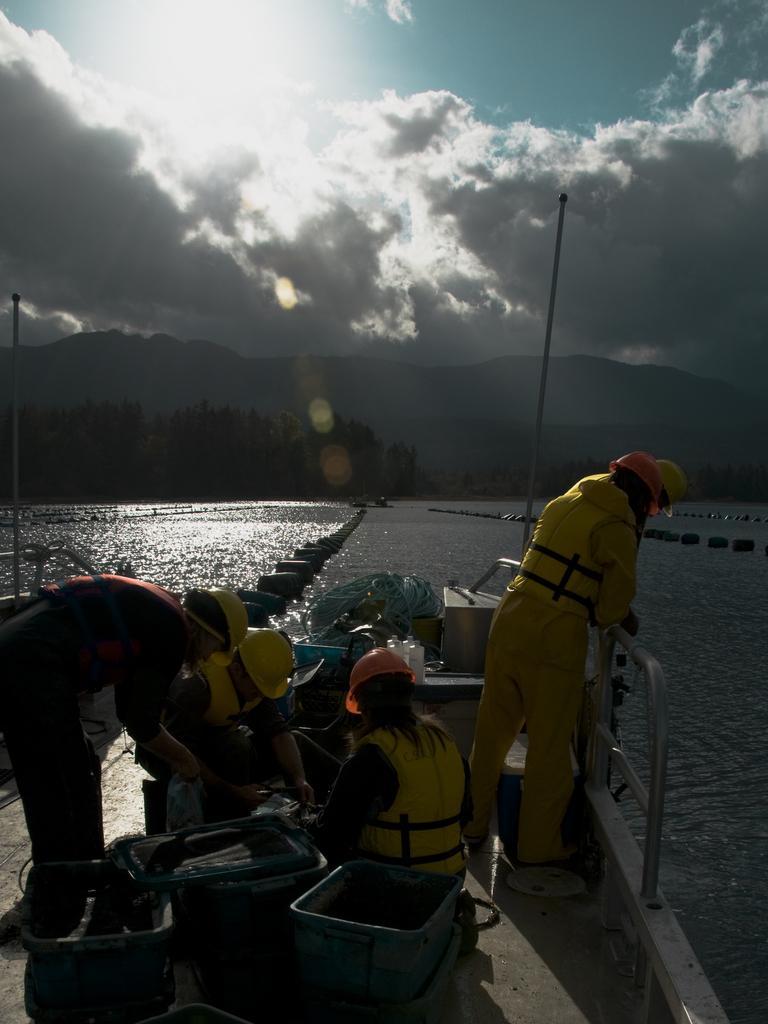Describe this image in one or two sentences. There is a ship sailing on the water and inside the ship there are total four people,they are doing some work and in the background there are plenty of trees and mountains. There is a bright sunshine in the sky. 